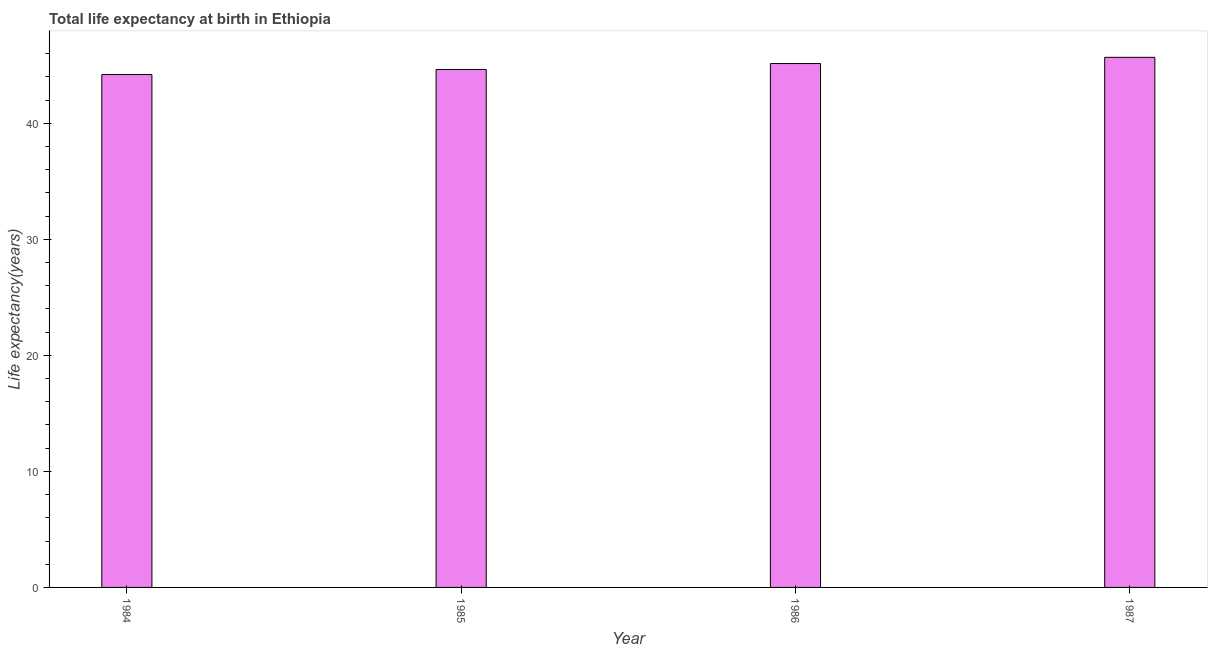Does the graph contain grids?
Provide a succinct answer. No. What is the title of the graph?
Your response must be concise. Total life expectancy at birth in Ethiopia. What is the label or title of the X-axis?
Your answer should be compact. Year. What is the label or title of the Y-axis?
Your answer should be very brief. Life expectancy(years). What is the life expectancy at birth in 1986?
Give a very brief answer. 45.14. Across all years, what is the maximum life expectancy at birth?
Offer a terse response. 45.68. Across all years, what is the minimum life expectancy at birth?
Make the answer very short. 44.2. In which year was the life expectancy at birth minimum?
Make the answer very short. 1984. What is the sum of the life expectancy at birth?
Ensure brevity in your answer.  179.65. What is the difference between the life expectancy at birth in 1986 and 1987?
Your response must be concise. -0.54. What is the average life expectancy at birth per year?
Provide a succinct answer. 44.91. What is the median life expectancy at birth?
Make the answer very short. 44.89. Do a majority of the years between 1987 and 1985 (inclusive) have life expectancy at birth greater than 24 years?
Ensure brevity in your answer.  Yes. What is the difference between the highest and the second highest life expectancy at birth?
Ensure brevity in your answer.  0.54. What is the difference between the highest and the lowest life expectancy at birth?
Offer a very short reply. 1.48. In how many years, is the life expectancy at birth greater than the average life expectancy at birth taken over all years?
Your response must be concise. 2. Are the values on the major ticks of Y-axis written in scientific E-notation?
Your response must be concise. No. What is the Life expectancy(years) of 1984?
Keep it short and to the point. 44.2. What is the Life expectancy(years) in 1985?
Your response must be concise. 44.63. What is the Life expectancy(years) of 1986?
Provide a succinct answer. 45.14. What is the Life expectancy(years) of 1987?
Provide a succinct answer. 45.68. What is the difference between the Life expectancy(years) in 1984 and 1985?
Provide a succinct answer. -0.43. What is the difference between the Life expectancy(years) in 1984 and 1986?
Your answer should be very brief. -0.95. What is the difference between the Life expectancy(years) in 1984 and 1987?
Your answer should be compact. -1.48. What is the difference between the Life expectancy(years) in 1985 and 1986?
Give a very brief answer. -0.51. What is the difference between the Life expectancy(years) in 1985 and 1987?
Your answer should be very brief. -1.05. What is the difference between the Life expectancy(years) in 1986 and 1987?
Your answer should be very brief. -0.53. What is the ratio of the Life expectancy(years) in 1984 to that in 1986?
Make the answer very short. 0.98. What is the ratio of the Life expectancy(years) in 1986 to that in 1987?
Your response must be concise. 0.99. 